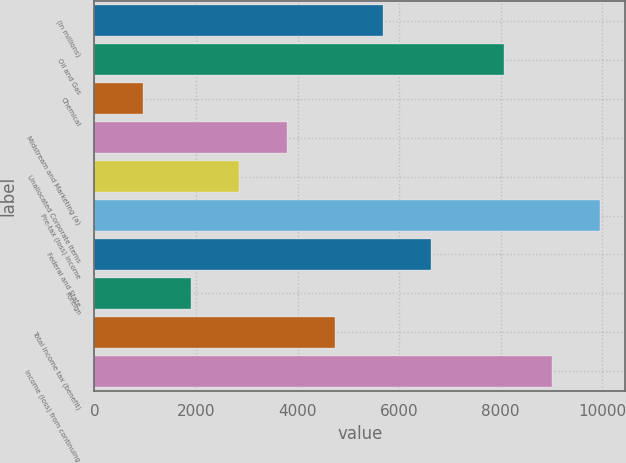<chart> <loc_0><loc_0><loc_500><loc_500><bar_chart><fcel>(in millions)<fcel>Oil and Gas<fcel>Chemical<fcel>Midstream and Marketing (a)<fcel>Unallocated Corporate Items<fcel>Pre-tax (loss) income<fcel>Federal and State<fcel>Foreign<fcel>Total income tax (benefit)<fcel>Income (loss) from continuing<nl><fcel>5691.2<fcel>8060<fcel>960.2<fcel>3798.8<fcel>2852.6<fcel>9952.4<fcel>6637.4<fcel>1906.4<fcel>4745<fcel>9006.2<nl></chart> 